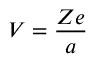Convert formula to latex. <formula><loc_0><loc_0><loc_500><loc_500>V = { \frac { Z e } { a } } \,</formula> 